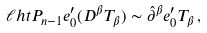<formula> <loc_0><loc_0><loc_500><loc_500>\ell h t P _ { n - 1 } e ^ { \prime } _ { 0 } ( D ^ { \beta } T _ { \beta } ) \sim \hat { \partial } ^ { \beta } e ^ { \prime } _ { 0 } T _ { \beta } \, ,</formula> 